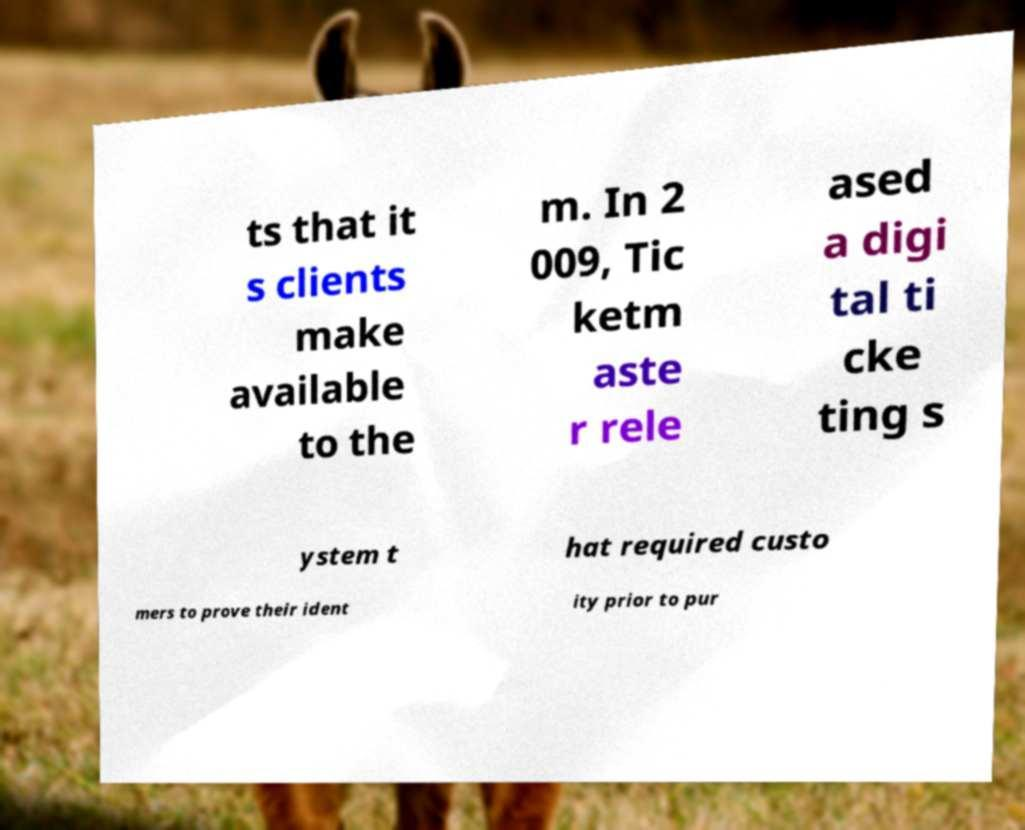What messages or text are displayed in this image? I need them in a readable, typed format. ts that it s clients make available to the m. In 2 009, Tic ketm aste r rele ased a digi tal ti cke ting s ystem t hat required custo mers to prove their ident ity prior to pur 